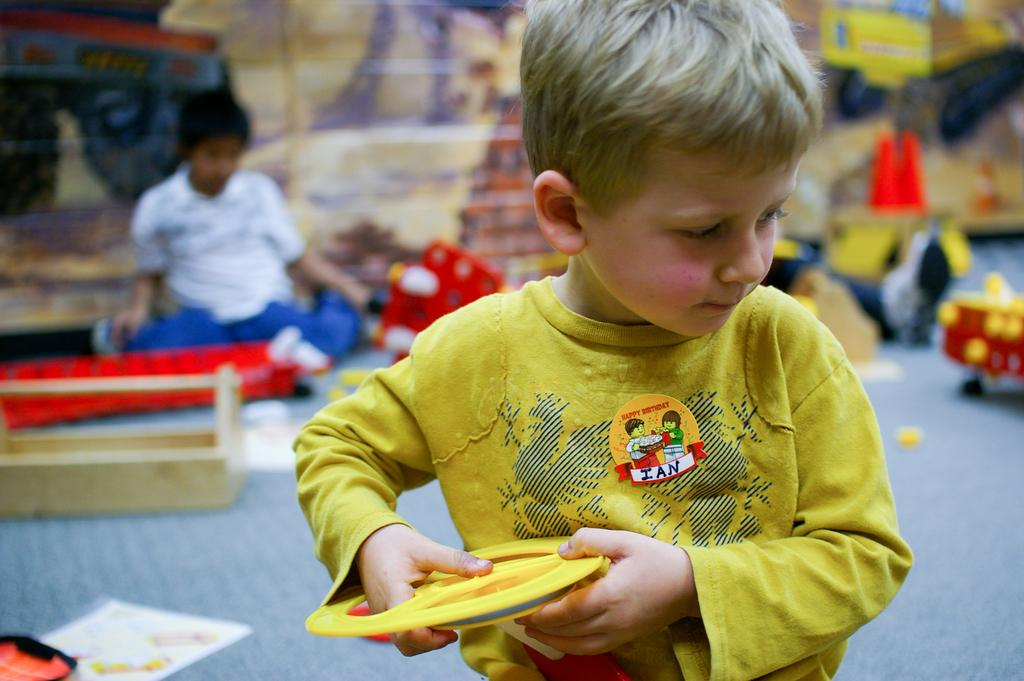What type of place is depicted in the image? The image appears to depict a play school. How many kids can be seen in the image? There are two kids in the image. What are the kids doing in the image? The kids are playing. What are the kids holding in their hands? The kids are holding objects in their hands. What condition are the books in the image? There are no books present in the image. 